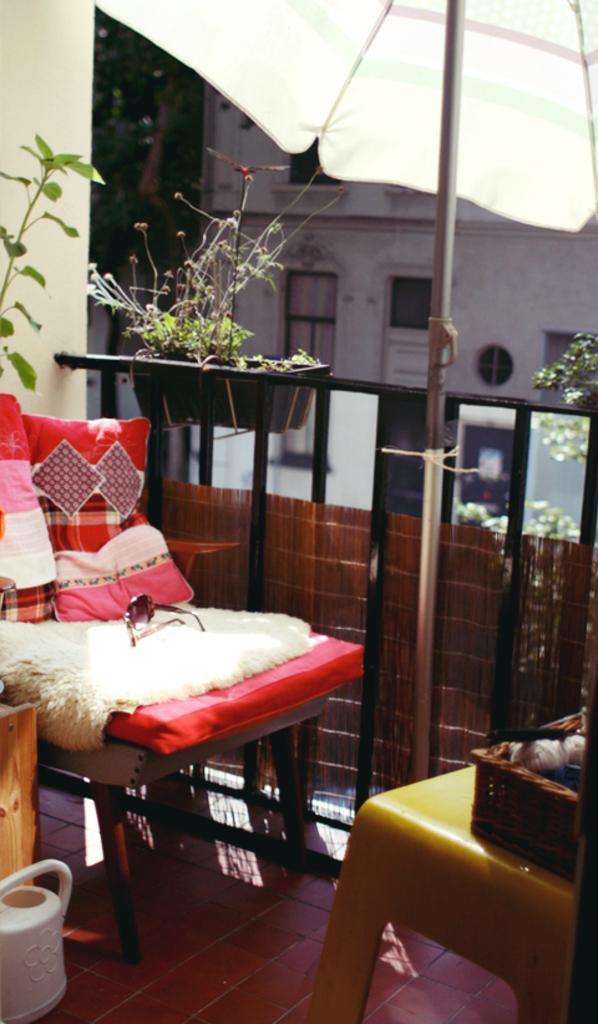Please provide a concise description of this image. There is a chair which has goggles on it and there are trees and a building in background. 